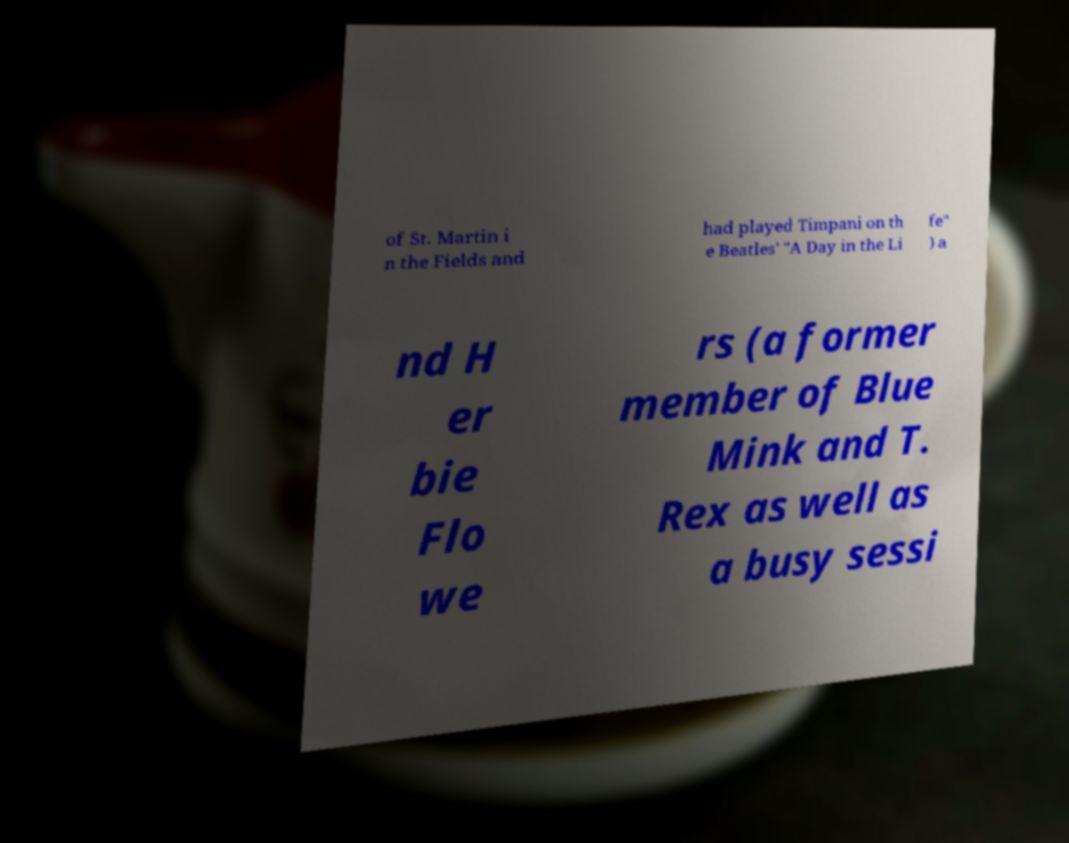Can you read and provide the text displayed in the image?This photo seems to have some interesting text. Can you extract and type it out for me? of St. Martin i n the Fields and had played Timpani on th e Beatles' "A Day in the Li fe" ) a nd H er bie Flo we rs (a former member of Blue Mink and T. Rex as well as a busy sessi 